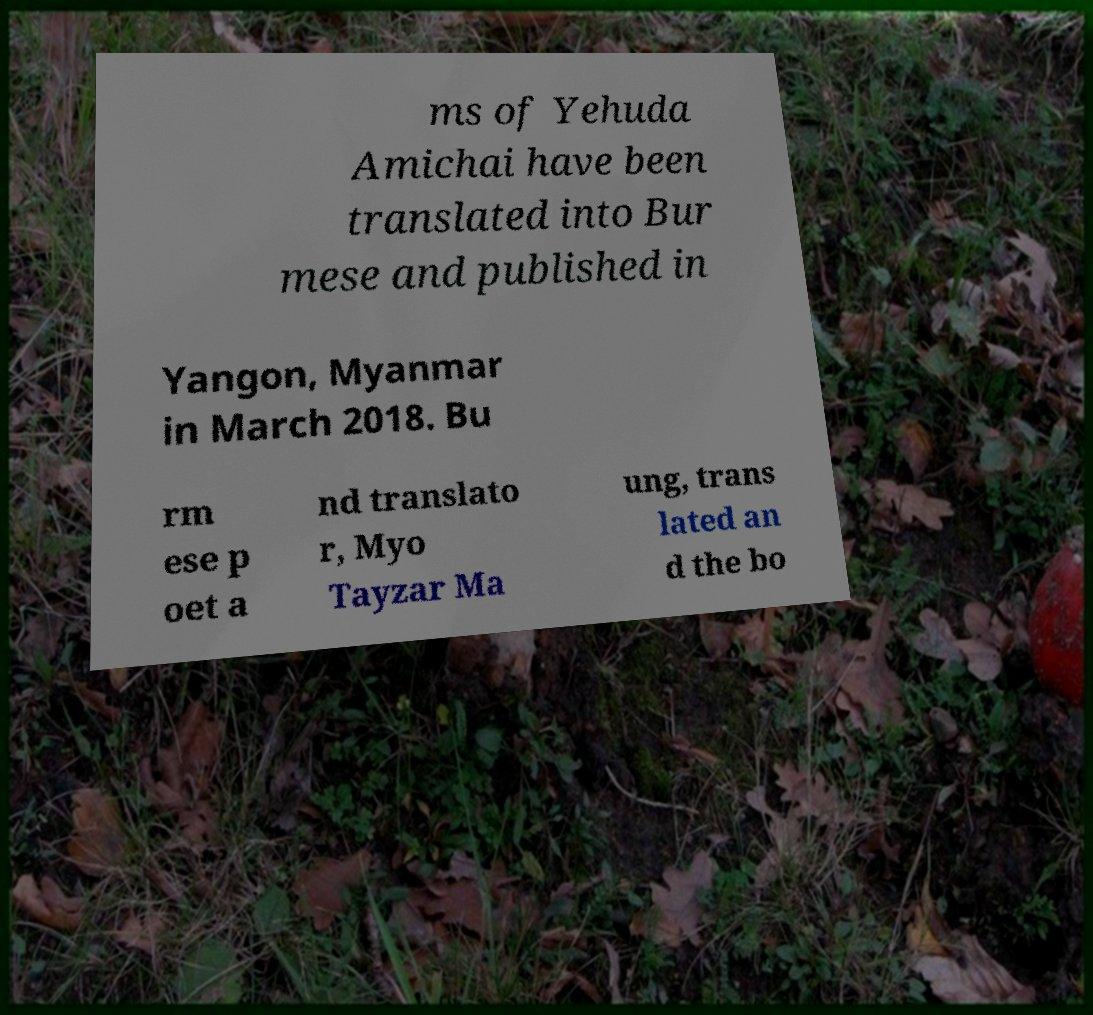Please identify and transcribe the text found in this image. ms of Yehuda Amichai have been translated into Bur mese and published in Yangon, Myanmar in March 2018. Bu rm ese p oet a nd translato r, Myo Tayzar Ma ung, trans lated an d the bo 